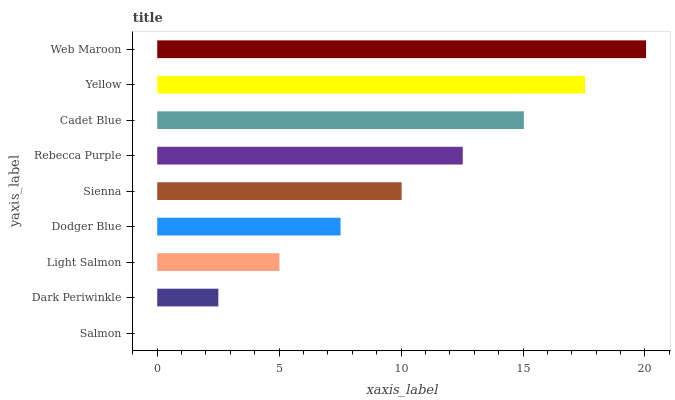Is Salmon the minimum?
Answer yes or no. Yes. Is Web Maroon the maximum?
Answer yes or no. Yes. Is Dark Periwinkle the minimum?
Answer yes or no. No. Is Dark Periwinkle the maximum?
Answer yes or no. No. Is Dark Periwinkle greater than Salmon?
Answer yes or no. Yes. Is Salmon less than Dark Periwinkle?
Answer yes or no. Yes. Is Salmon greater than Dark Periwinkle?
Answer yes or no. No. Is Dark Periwinkle less than Salmon?
Answer yes or no. No. Is Sienna the high median?
Answer yes or no. Yes. Is Sienna the low median?
Answer yes or no. Yes. Is Cadet Blue the high median?
Answer yes or no. No. Is Cadet Blue the low median?
Answer yes or no. No. 